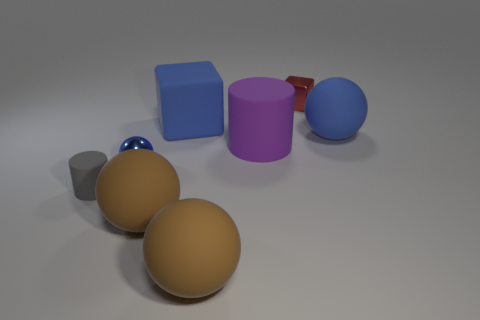There is a matte cylinder on the right side of the small cylinder; what size is it?
Your answer should be compact. Large. Are there fewer large blue matte cubes left of the small blue object than small green balls?
Offer a terse response. No. Do the tiny metallic ball and the small cube have the same color?
Ensure brevity in your answer.  No. Is there anything else that has the same shape as the gray matte object?
Give a very brief answer. Yes. Is the number of gray cylinders less than the number of small objects?
Your answer should be compact. Yes. The tiny metal object that is in front of the big rubber object right of the shiny cube is what color?
Offer a very short reply. Blue. The blue sphere behind the blue sphere in front of the cylinder behind the tiny gray cylinder is made of what material?
Your answer should be compact. Rubber. Is the size of the metallic object in front of the red metal cube the same as the large blue block?
Your response must be concise. No. What material is the cylinder that is to the left of the blue metallic object?
Provide a short and direct response. Rubber. Are there more small metal things than tiny purple matte cylinders?
Provide a short and direct response. Yes. 